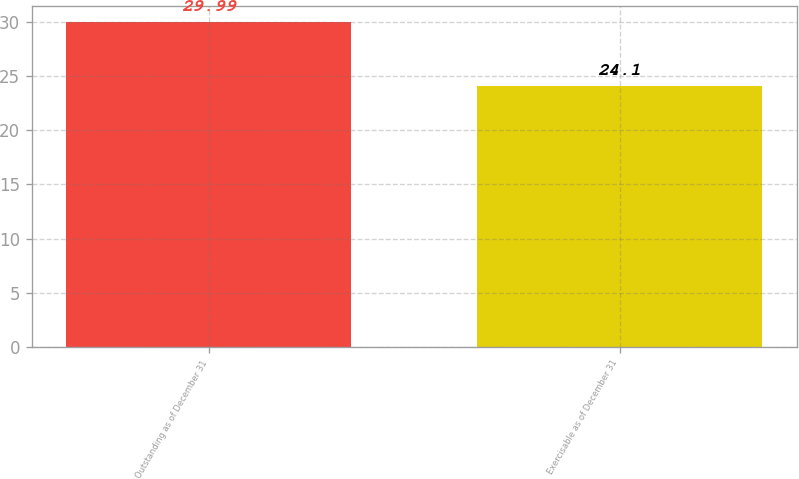<chart> <loc_0><loc_0><loc_500><loc_500><bar_chart><fcel>Outstanding as of December 31<fcel>Exercisable as of December 31<nl><fcel>29.99<fcel>24.1<nl></chart> 